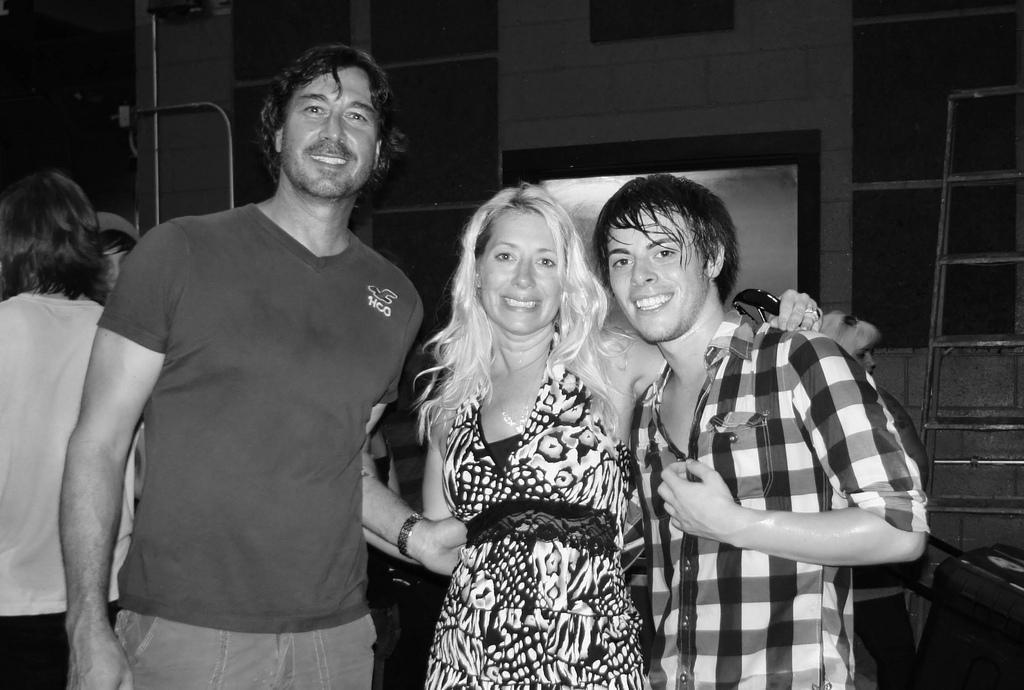In one or two sentences, can you explain what this image depicts? In this image we can see there are people standing on the ground and at the back there is a stand and building. 